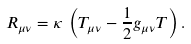<formula> <loc_0><loc_0><loc_500><loc_500>R _ { \mu \nu } = \kappa \, \left ( T _ { \mu \nu } - \frac { 1 } { 2 } g _ { \mu \nu } T \right ) .</formula> 